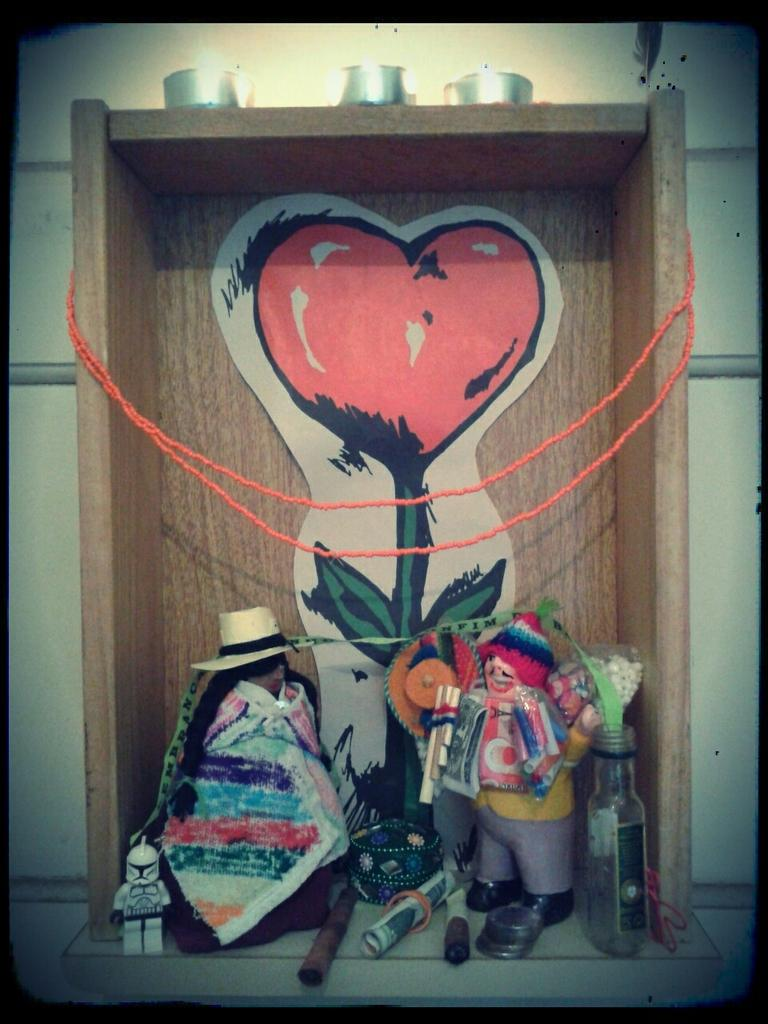What types of objects can be seen on the ground in the image? There are toys, rope, and a wooden object with an art on the ground in the image. Can you describe the wall visible in the image? Unfortunately, the facts provided do not give any details about the wall, so we cannot describe it. What type of wire is being used to create the art on the wooden object? There is no wire present in the image; the wooden object has an art on it, but no wire is mentioned or visible. 